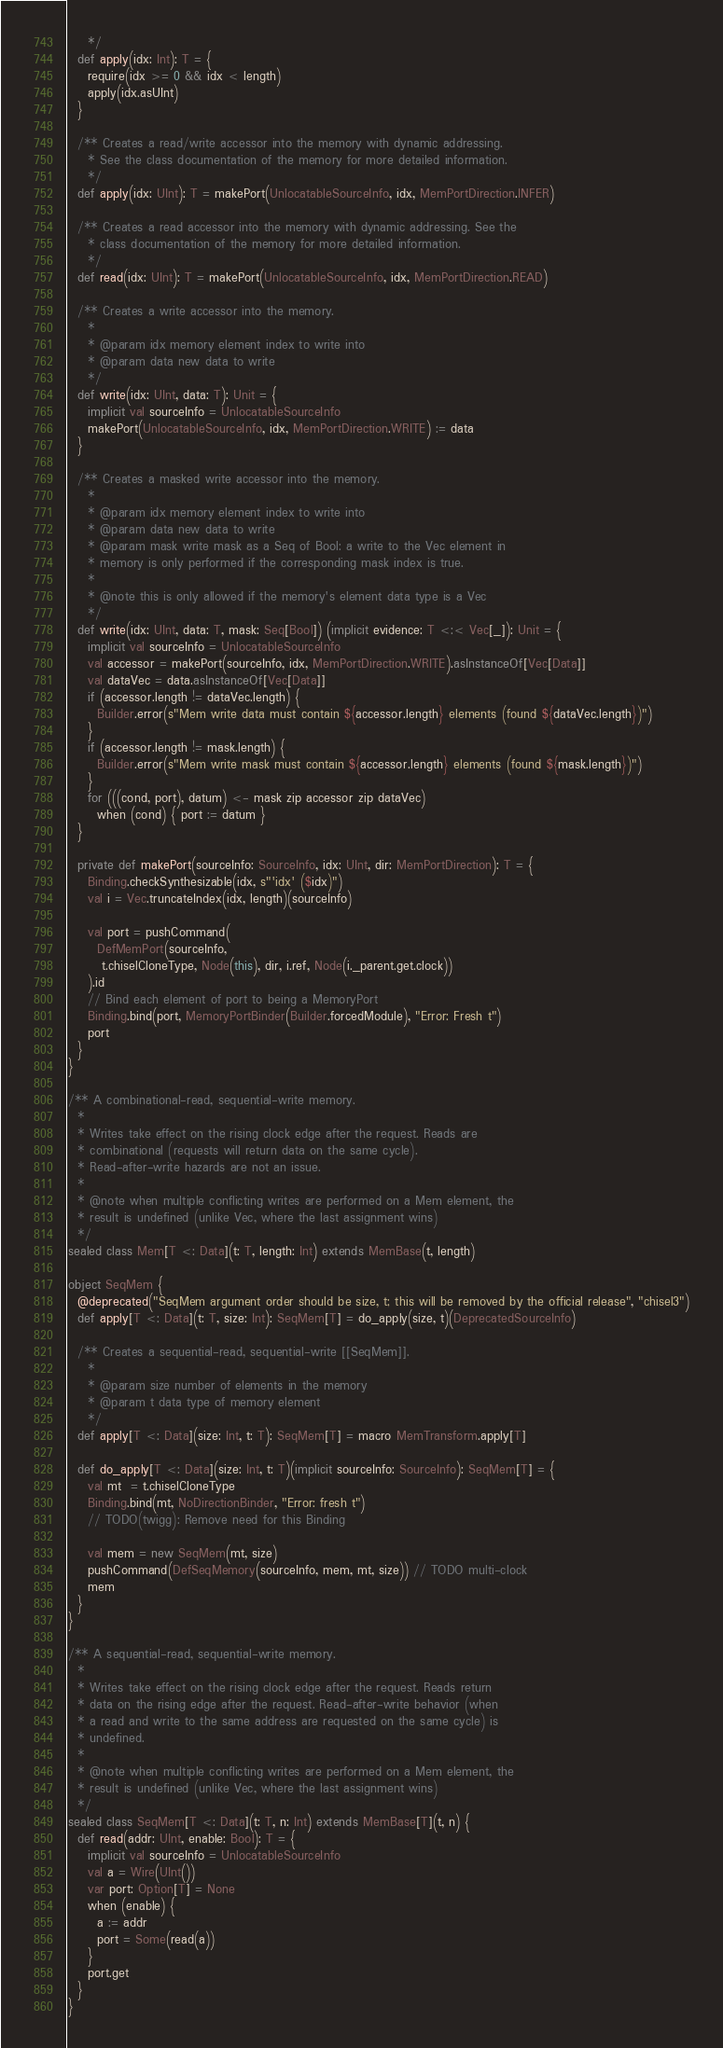<code> <loc_0><loc_0><loc_500><loc_500><_Scala_>    */
  def apply(idx: Int): T = {
    require(idx >= 0 && idx < length)
    apply(idx.asUInt)
  }

  /** Creates a read/write accessor into the memory with dynamic addressing.
    * See the class documentation of the memory for more detailed information.
    */
  def apply(idx: UInt): T = makePort(UnlocatableSourceInfo, idx, MemPortDirection.INFER)

  /** Creates a read accessor into the memory with dynamic addressing. See the
    * class documentation of the memory for more detailed information.
    */
  def read(idx: UInt): T = makePort(UnlocatableSourceInfo, idx, MemPortDirection.READ)

  /** Creates a write accessor into the memory.
    *
    * @param idx memory element index to write into
    * @param data new data to write
    */
  def write(idx: UInt, data: T): Unit = {
    implicit val sourceInfo = UnlocatableSourceInfo
    makePort(UnlocatableSourceInfo, idx, MemPortDirection.WRITE) := data
  }

  /** Creates a masked write accessor into the memory.
    *
    * @param idx memory element index to write into
    * @param data new data to write
    * @param mask write mask as a Seq of Bool: a write to the Vec element in
    * memory is only performed if the corresponding mask index is true.
    *
    * @note this is only allowed if the memory's element data type is a Vec
    */
  def write(idx: UInt, data: T, mask: Seq[Bool]) (implicit evidence: T <:< Vec[_]): Unit = {
    implicit val sourceInfo = UnlocatableSourceInfo
    val accessor = makePort(sourceInfo, idx, MemPortDirection.WRITE).asInstanceOf[Vec[Data]]
    val dataVec = data.asInstanceOf[Vec[Data]]
    if (accessor.length != dataVec.length) {
      Builder.error(s"Mem write data must contain ${accessor.length} elements (found ${dataVec.length})")
    }
    if (accessor.length != mask.length) {
      Builder.error(s"Mem write mask must contain ${accessor.length} elements (found ${mask.length})")
    }
    for (((cond, port), datum) <- mask zip accessor zip dataVec)
      when (cond) { port := datum }
  }

  private def makePort(sourceInfo: SourceInfo, idx: UInt, dir: MemPortDirection): T = {
    Binding.checkSynthesizable(idx, s"'idx' ($idx)")
    val i = Vec.truncateIndex(idx, length)(sourceInfo)

    val port = pushCommand(
      DefMemPort(sourceInfo,
       t.chiselCloneType, Node(this), dir, i.ref, Node(i._parent.get.clock))
    ).id
    // Bind each element of port to being a MemoryPort
    Binding.bind(port, MemoryPortBinder(Builder.forcedModule), "Error: Fresh t")
    port
  }
}

/** A combinational-read, sequential-write memory.
  *
  * Writes take effect on the rising clock edge after the request. Reads are
  * combinational (requests will return data on the same cycle).
  * Read-after-write hazards are not an issue.
  *
  * @note when multiple conflicting writes are performed on a Mem element, the
  * result is undefined (unlike Vec, where the last assignment wins)
  */
sealed class Mem[T <: Data](t: T, length: Int) extends MemBase(t, length)

object SeqMem {
  @deprecated("SeqMem argument order should be size, t; this will be removed by the official release", "chisel3")
  def apply[T <: Data](t: T, size: Int): SeqMem[T] = do_apply(size, t)(DeprecatedSourceInfo)

  /** Creates a sequential-read, sequential-write [[SeqMem]].
    *
    * @param size number of elements in the memory
    * @param t data type of memory element
    */
  def apply[T <: Data](size: Int, t: T): SeqMem[T] = macro MemTransform.apply[T]

  def do_apply[T <: Data](size: Int, t: T)(implicit sourceInfo: SourceInfo): SeqMem[T] = {
    val mt  = t.chiselCloneType
    Binding.bind(mt, NoDirectionBinder, "Error: fresh t")
    // TODO(twigg): Remove need for this Binding

    val mem = new SeqMem(mt, size)
    pushCommand(DefSeqMemory(sourceInfo, mem, mt, size)) // TODO multi-clock
    mem
  }
}

/** A sequential-read, sequential-write memory.
  *
  * Writes take effect on the rising clock edge after the request. Reads return
  * data on the rising edge after the request. Read-after-write behavior (when
  * a read and write to the same address are requested on the same cycle) is
  * undefined.
  *
  * @note when multiple conflicting writes are performed on a Mem element, the
  * result is undefined (unlike Vec, where the last assignment wins)
  */
sealed class SeqMem[T <: Data](t: T, n: Int) extends MemBase[T](t, n) {
  def read(addr: UInt, enable: Bool): T = {
    implicit val sourceInfo = UnlocatableSourceInfo
    val a = Wire(UInt())
    var port: Option[T] = None
    when (enable) {
      a := addr
      port = Some(read(a))
    }
    port.get
  }
}
</code> 